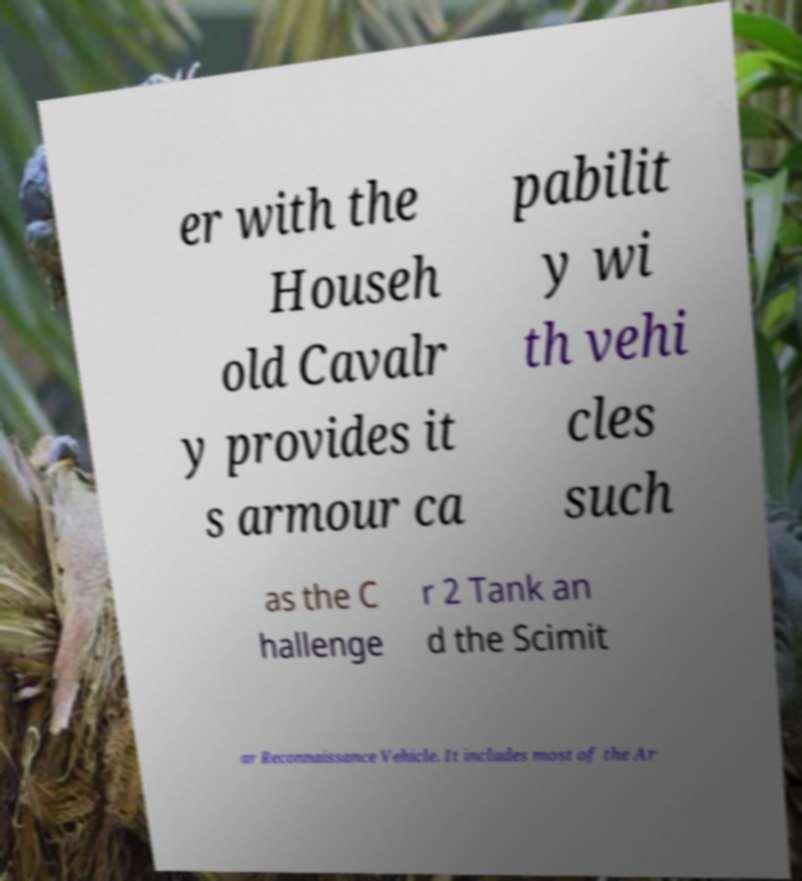Can you read and provide the text displayed in the image?This photo seems to have some interesting text. Can you extract and type it out for me? er with the Househ old Cavalr y provides it s armour ca pabilit y wi th vehi cles such as the C hallenge r 2 Tank an d the Scimit ar Reconnaissance Vehicle. It includes most of the Ar 